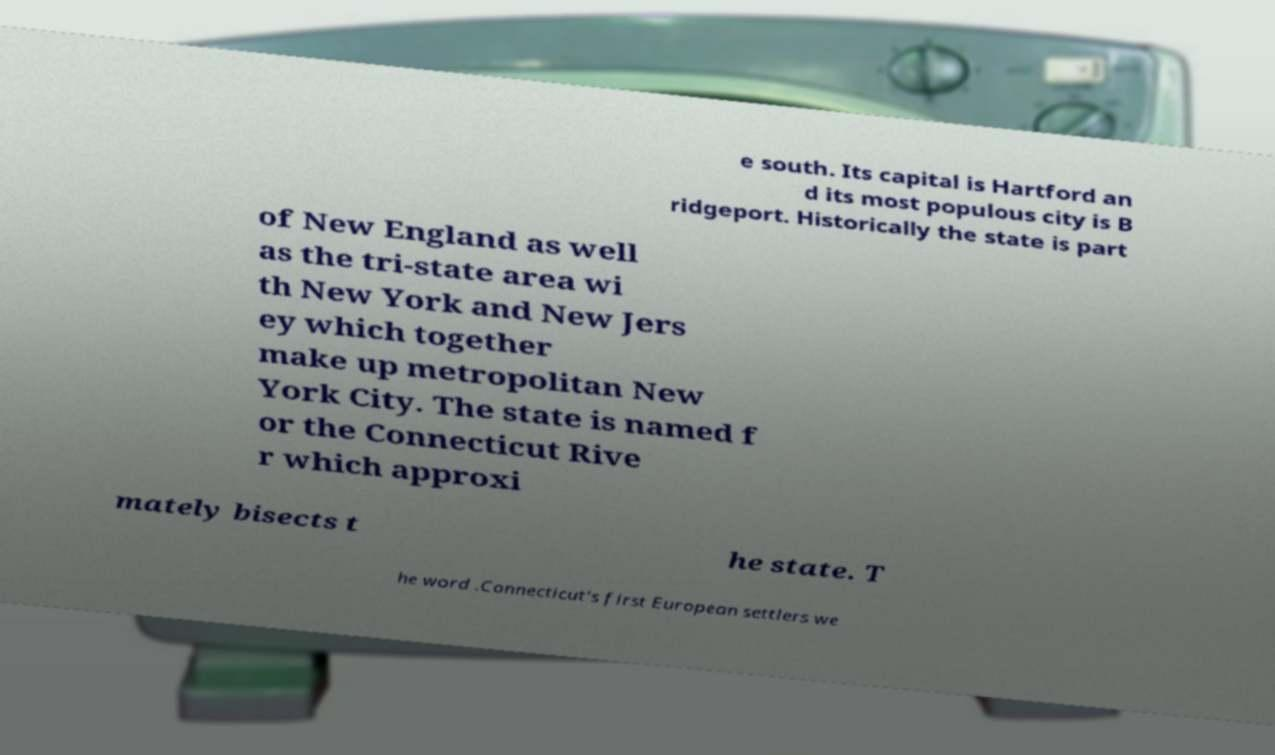For documentation purposes, I need the text within this image transcribed. Could you provide that? e south. Its capital is Hartford an d its most populous city is B ridgeport. Historically the state is part of New England as well as the tri-state area wi th New York and New Jers ey which together make up metropolitan New York City. The state is named f or the Connecticut Rive r which approxi mately bisects t he state. T he word .Connecticut's first European settlers we 